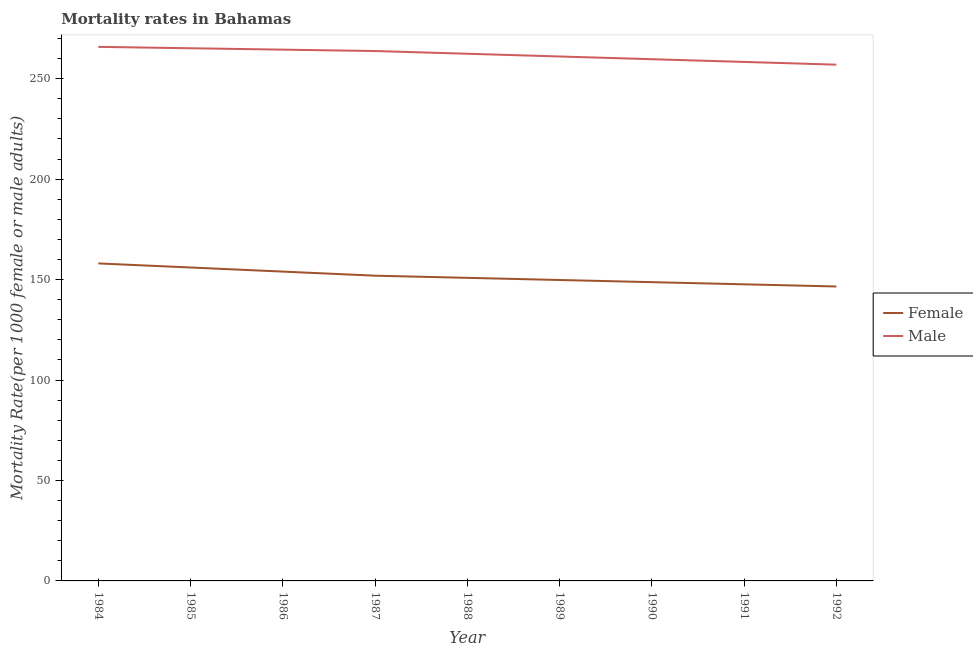How many different coloured lines are there?
Provide a short and direct response. 2. Does the line corresponding to female mortality rate intersect with the line corresponding to male mortality rate?
Give a very brief answer. No. Is the number of lines equal to the number of legend labels?
Make the answer very short. Yes. What is the female mortality rate in 1991?
Your answer should be very brief. 147.63. Across all years, what is the maximum female mortality rate?
Give a very brief answer. 158.03. Across all years, what is the minimum male mortality rate?
Your answer should be compact. 256.96. In which year was the male mortality rate maximum?
Ensure brevity in your answer.  1984. What is the total female mortality rate in the graph?
Your response must be concise. 1363.4. What is the difference between the male mortality rate in 1988 and that in 1990?
Offer a very short reply. 2.71. What is the difference between the female mortality rate in 1986 and the male mortality rate in 1984?
Ensure brevity in your answer.  -111.86. What is the average female mortality rate per year?
Ensure brevity in your answer.  151.49. In the year 1992, what is the difference between the male mortality rate and female mortality rate?
Your response must be concise. 110.41. What is the ratio of the male mortality rate in 1987 to that in 1991?
Your response must be concise. 1.02. Is the male mortality rate in 1985 less than that in 1989?
Your response must be concise. No. Is the difference between the male mortality rate in 1988 and 1991 greater than the difference between the female mortality rate in 1988 and 1991?
Make the answer very short. Yes. What is the difference between the highest and the second highest female mortality rate?
Offer a very short reply. 2.04. What is the difference between the highest and the lowest male mortality rate?
Your answer should be compact. 8.86. Is the sum of the male mortality rate in 1986 and 1992 greater than the maximum female mortality rate across all years?
Your response must be concise. Yes. Does the female mortality rate monotonically increase over the years?
Keep it short and to the point. No. How many lines are there?
Give a very brief answer. 2. What is the difference between two consecutive major ticks on the Y-axis?
Ensure brevity in your answer.  50. How are the legend labels stacked?
Provide a short and direct response. Vertical. What is the title of the graph?
Offer a terse response. Mortality rates in Bahamas. What is the label or title of the X-axis?
Your answer should be compact. Year. What is the label or title of the Y-axis?
Ensure brevity in your answer.  Mortality Rate(per 1000 female or male adults). What is the Mortality Rate(per 1000 female or male adults) in Female in 1984?
Give a very brief answer. 158.03. What is the Mortality Rate(per 1000 female or male adults) in Male in 1984?
Provide a short and direct response. 265.82. What is the Mortality Rate(per 1000 female or male adults) in Female in 1985?
Give a very brief answer. 155.99. What is the Mortality Rate(per 1000 female or male adults) of Male in 1985?
Keep it short and to the point. 265.12. What is the Mortality Rate(per 1000 female or male adults) of Female in 1986?
Provide a short and direct response. 153.96. What is the Mortality Rate(per 1000 female or male adults) of Male in 1986?
Provide a succinct answer. 264.43. What is the Mortality Rate(per 1000 female or male adults) in Female in 1987?
Provide a short and direct response. 151.92. What is the Mortality Rate(per 1000 female or male adults) in Male in 1987?
Ensure brevity in your answer.  263.74. What is the Mortality Rate(per 1000 female or male adults) in Female in 1988?
Offer a very short reply. 150.85. What is the Mortality Rate(per 1000 female or male adults) of Male in 1988?
Keep it short and to the point. 262.38. What is the Mortality Rate(per 1000 female or male adults) of Female in 1989?
Make the answer very short. 149.77. What is the Mortality Rate(per 1000 female or male adults) of Male in 1989?
Provide a succinct answer. 261.03. What is the Mortality Rate(per 1000 female or male adults) in Female in 1990?
Offer a terse response. 148.7. What is the Mortality Rate(per 1000 female or male adults) of Male in 1990?
Give a very brief answer. 259.67. What is the Mortality Rate(per 1000 female or male adults) of Female in 1991?
Your answer should be compact. 147.63. What is the Mortality Rate(per 1000 female or male adults) of Male in 1991?
Offer a very short reply. 258.32. What is the Mortality Rate(per 1000 female or male adults) in Female in 1992?
Offer a very short reply. 146.55. What is the Mortality Rate(per 1000 female or male adults) in Male in 1992?
Keep it short and to the point. 256.96. Across all years, what is the maximum Mortality Rate(per 1000 female or male adults) of Female?
Offer a terse response. 158.03. Across all years, what is the maximum Mortality Rate(per 1000 female or male adults) of Male?
Offer a very short reply. 265.82. Across all years, what is the minimum Mortality Rate(per 1000 female or male adults) in Female?
Provide a short and direct response. 146.55. Across all years, what is the minimum Mortality Rate(per 1000 female or male adults) of Male?
Provide a short and direct response. 256.96. What is the total Mortality Rate(per 1000 female or male adults) in Female in the graph?
Keep it short and to the point. 1363.4. What is the total Mortality Rate(per 1000 female or male adults) in Male in the graph?
Make the answer very short. 2357.48. What is the difference between the Mortality Rate(per 1000 female or male adults) of Female in 1984 and that in 1985?
Offer a terse response. 2.04. What is the difference between the Mortality Rate(per 1000 female or male adults) of Male in 1984 and that in 1985?
Provide a short and direct response. 0.69. What is the difference between the Mortality Rate(per 1000 female or male adults) in Female in 1984 and that in 1986?
Give a very brief answer. 4.07. What is the difference between the Mortality Rate(per 1000 female or male adults) in Male in 1984 and that in 1986?
Provide a short and direct response. 1.38. What is the difference between the Mortality Rate(per 1000 female or male adults) of Female in 1984 and that in 1987?
Give a very brief answer. 6.11. What is the difference between the Mortality Rate(per 1000 female or male adults) of Male in 1984 and that in 1987?
Keep it short and to the point. 2.08. What is the difference between the Mortality Rate(per 1000 female or male adults) in Female in 1984 and that in 1988?
Give a very brief answer. 7.18. What is the difference between the Mortality Rate(per 1000 female or male adults) in Male in 1984 and that in 1988?
Your answer should be very brief. 3.43. What is the difference between the Mortality Rate(per 1000 female or male adults) in Female in 1984 and that in 1989?
Provide a succinct answer. 8.26. What is the difference between the Mortality Rate(per 1000 female or male adults) in Male in 1984 and that in 1989?
Give a very brief answer. 4.79. What is the difference between the Mortality Rate(per 1000 female or male adults) in Female in 1984 and that in 1990?
Keep it short and to the point. 9.33. What is the difference between the Mortality Rate(per 1000 female or male adults) in Male in 1984 and that in 1990?
Provide a succinct answer. 6.14. What is the difference between the Mortality Rate(per 1000 female or male adults) in Female in 1984 and that in 1991?
Your answer should be very brief. 10.4. What is the difference between the Mortality Rate(per 1000 female or male adults) of Male in 1984 and that in 1991?
Offer a terse response. 7.5. What is the difference between the Mortality Rate(per 1000 female or male adults) in Female in 1984 and that in 1992?
Your response must be concise. 11.48. What is the difference between the Mortality Rate(per 1000 female or male adults) in Male in 1984 and that in 1992?
Provide a short and direct response. 8.86. What is the difference between the Mortality Rate(per 1000 female or male adults) in Female in 1985 and that in 1986?
Offer a very short reply. 2.04. What is the difference between the Mortality Rate(per 1000 female or male adults) of Male in 1985 and that in 1986?
Give a very brief answer. 0.69. What is the difference between the Mortality Rate(per 1000 female or male adults) of Female in 1985 and that in 1987?
Ensure brevity in your answer.  4.07. What is the difference between the Mortality Rate(per 1000 female or male adults) in Male in 1985 and that in 1987?
Your response must be concise. 1.38. What is the difference between the Mortality Rate(per 1000 female or male adults) in Female in 1985 and that in 1988?
Offer a terse response. 5.15. What is the difference between the Mortality Rate(per 1000 female or male adults) of Male in 1985 and that in 1988?
Provide a short and direct response. 2.74. What is the difference between the Mortality Rate(per 1000 female or male adults) in Female in 1985 and that in 1989?
Make the answer very short. 6.22. What is the difference between the Mortality Rate(per 1000 female or male adults) of Male in 1985 and that in 1989?
Your response must be concise. 4.1. What is the difference between the Mortality Rate(per 1000 female or male adults) of Female in 1985 and that in 1990?
Offer a very short reply. 7.29. What is the difference between the Mortality Rate(per 1000 female or male adults) of Male in 1985 and that in 1990?
Give a very brief answer. 5.45. What is the difference between the Mortality Rate(per 1000 female or male adults) of Female in 1985 and that in 1991?
Your answer should be very brief. 8.37. What is the difference between the Mortality Rate(per 1000 female or male adults) in Male in 1985 and that in 1991?
Provide a short and direct response. 6.81. What is the difference between the Mortality Rate(per 1000 female or male adults) in Female in 1985 and that in 1992?
Make the answer very short. 9.44. What is the difference between the Mortality Rate(per 1000 female or male adults) of Male in 1985 and that in 1992?
Offer a terse response. 8.16. What is the difference between the Mortality Rate(per 1000 female or male adults) of Female in 1986 and that in 1987?
Make the answer very short. 2.04. What is the difference between the Mortality Rate(per 1000 female or male adults) of Male in 1986 and that in 1987?
Ensure brevity in your answer.  0.69. What is the difference between the Mortality Rate(per 1000 female or male adults) in Female in 1986 and that in 1988?
Offer a very short reply. 3.11. What is the difference between the Mortality Rate(per 1000 female or male adults) in Male in 1986 and that in 1988?
Give a very brief answer. 2.05. What is the difference between the Mortality Rate(per 1000 female or male adults) of Female in 1986 and that in 1989?
Make the answer very short. 4.18. What is the difference between the Mortality Rate(per 1000 female or male adults) of Male in 1986 and that in 1989?
Keep it short and to the point. 3.4. What is the difference between the Mortality Rate(per 1000 female or male adults) of Female in 1986 and that in 1990?
Your answer should be very brief. 5.26. What is the difference between the Mortality Rate(per 1000 female or male adults) in Male in 1986 and that in 1990?
Your answer should be compact. 4.76. What is the difference between the Mortality Rate(per 1000 female or male adults) in Female in 1986 and that in 1991?
Your answer should be compact. 6.33. What is the difference between the Mortality Rate(per 1000 female or male adults) of Male in 1986 and that in 1991?
Make the answer very short. 6.12. What is the difference between the Mortality Rate(per 1000 female or male adults) in Female in 1986 and that in 1992?
Provide a succinct answer. 7.41. What is the difference between the Mortality Rate(per 1000 female or male adults) of Male in 1986 and that in 1992?
Your response must be concise. 7.47. What is the difference between the Mortality Rate(per 1000 female or male adults) of Female in 1987 and that in 1988?
Make the answer very short. 1.07. What is the difference between the Mortality Rate(per 1000 female or male adults) in Male in 1987 and that in 1988?
Offer a very short reply. 1.36. What is the difference between the Mortality Rate(per 1000 female or male adults) in Female in 1987 and that in 1989?
Your response must be concise. 2.15. What is the difference between the Mortality Rate(per 1000 female or male adults) of Male in 1987 and that in 1989?
Your answer should be very brief. 2.71. What is the difference between the Mortality Rate(per 1000 female or male adults) in Female in 1987 and that in 1990?
Offer a very short reply. 3.22. What is the difference between the Mortality Rate(per 1000 female or male adults) of Male in 1987 and that in 1990?
Ensure brevity in your answer.  4.07. What is the difference between the Mortality Rate(per 1000 female or male adults) of Female in 1987 and that in 1991?
Keep it short and to the point. 4.3. What is the difference between the Mortality Rate(per 1000 female or male adults) in Male in 1987 and that in 1991?
Your answer should be very brief. 5.42. What is the difference between the Mortality Rate(per 1000 female or male adults) of Female in 1987 and that in 1992?
Provide a short and direct response. 5.37. What is the difference between the Mortality Rate(per 1000 female or male adults) of Male in 1987 and that in 1992?
Keep it short and to the point. 6.78. What is the difference between the Mortality Rate(per 1000 female or male adults) in Female in 1988 and that in 1989?
Your answer should be very brief. 1.07. What is the difference between the Mortality Rate(per 1000 female or male adults) in Male in 1988 and that in 1989?
Offer a very short reply. 1.36. What is the difference between the Mortality Rate(per 1000 female or male adults) of Female in 1988 and that in 1990?
Your response must be concise. 2.15. What is the difference between the Mortality Rate(per 1000 female or male adults) of Male in 1988 and that in 1990?
Your response must be concise. 2.71. What is the difference between the Mortality Rate(per 1000 female or male adults) of Female in 1988 and that in 1991?
Offer a very short reply. 3.22. What is the difference between the Mortality Rate(per 1000 female or male adults) in Male in 1988 and that in 1991?
Keep it short and to the point. 4.07. What is the difference between the Mortality Rate(per 1000 female or male adults) of Female in 1988 and that in 1992?
Provide a succinct answer. 4.3. What is the difference between the Mortality Rate(per 1000 female or male adults) of Male in 1988 and that in 1992?
Offer a terse response. 5.42. What is the difference between the Mortality Rate(per 1000 female or male adults) in Female in 1989 and that in 1990?
Ensure brevity in your answer.  1.07. What is the difference between the Mortality Rate(per 1000 female or male adults) of Male in 1989 and that in 1990?
Offer a very short reply. 1.36. What is the difference between the Mortality Rate(per 1000 female or male adults) of Female in 1989 and that in 1991?
Offer a very short reply. 2.15. What is the difference between the Mortality Rate(per 1000 female or male adults) in Male in 1989 and that in 1991?
Your response must be concise. 2.71. What is the difference between the Mortality Rate(per 1000 female or male adults) of Female in 1989 and that in 1992?
Give a very brief answer. 3.22. What is the difference between the Mortality Rate(per 1000 female or male adults) in Male in 1989 and that in 1992?
Give a very brief answer. 4.07. What is the difference between the Mortality Rate(per 1000 female or male adults) of Female in 1990 and that in 1991?
Your response must be concise. 1.07. What is the difference between the Mortality Rate(per 1000 female or male adults) of Male in 1990 and that in 1991?
Your answer should be compact. 1.36. What is the difference between the Mortality Rate(per 1000 female or male adults) of Female in 1990 and that in 1992?
Provide a short and direct response. 2.15. What is the difference between the Mortality Rate(per 1000 female or male adults) in Male in 1990 and that in 1992?
Provide a succinct answer. 2.71. What is the difference between the Mortality Rate(per 1000 female or male adults) of Female in 1991 and that in 1992?
Your answer should be very brief. 1.07. What is the difference between the Mortality Rate(per 1000 female or male adults) of Male in 1991 and that in 1992?
Give a very brief answer. 1.36. What is the difference between the Mortality Rate(per 1000 female or male adults) in Female in 1984 and the Mortality Rate(per 1000 female or male adults) in Male in 1985?
Provide a short and direct response. -107.09. What is the difference between the Mortality Rate(per 1000 female or male adults) of Female in 1984 and the Mortality Rate(per 1000 female or male adults) of Male in 1986?
Your answer should be very brief. -106.4. What is the difference between the Mortality Rate(per 1000 female or male adults) of Female in 1984 and the Mortality Rate(per 1000 female or male adults) of Male in 1987?
Your answer should be compact. -105.71. What is the difference between the Mortality Rate(per 1000 female or male adults) in Female in 1984 and the Mortality Rate(per 1000 female or male adults) in Male in 1988?
Provide a short and direct response. -104.36. What is the difference between the Mortality Rate(per 1000 female or male adults) of Female in 1984 and the Mortality Rate(per 1000 female or male adults) of Male in 1989?
Provide a short and direct response. -103. What is the difference between the Mortality Rate(per 1000 female or male adults) in Female in 1984 and the Mortality Rate(per 1000 female or male adults) in Male in 1990?
Your response must be concise. -101.64. What is the difference between the Mortality Rate(per 1000 female or male adults) of Female in 1984 and the Mortality Rate(per 1000 female or male adults) of Male in 1991?
Make the answer very short. -100.29. What is the difference between the Mortality Rate(per 1000 female or male adults) of Female in 1984 and the Mortality Rate(per 1000 female or male adults) of Male in 1992?
Offer a very short reply. -98.93. What is the difference between the Mortality Rate(per 1000 female or male adults) in Female in 1985 and the Mortality Rate(per 1000 female or male adults) in Male in 1986?
Your answer should be compact. -108.44. What is the difference between the Mortality Rate(per 1000 female or male adults) of Female in 1985 and the Mortality Rate(per 1000 female or male adults) of Male in 1987?
Your answer should be compact. -107.75. What is the difference between the Mortality Rate(per 1000 female or male adults) of Female in 1985 and the Mortality Rate(per 1000 female or male adults) of Male in 1988?
Ensure brevity in your answer.  -106.39. What is the difference between the Mortality Rate(per 1000 female or male adults) of Female in 1985 and the Mortality Rate(per 1000 female or male adults) of Male in 1989?
Provide a succinct answer. -105.03. What is the difference between the Mortality Rate(per 1000 female or male adults) of Female in 1985 and the Mortality Rate(per 1000 female or male adults) of Male in 1990?
Make the answer very short. -103.68. What is the difference between the Mortality Rate(per 1000 female or male adults) in Female in 1985 and the Mortality Rate(per 1000 female or male adults) in Male in 1991?
Make the answer very short. -102.32. What is the difference between the Mortality Rate(per 1000 female or male adults) in Female in 1985 and the Mortality Rate(per 1000 female or male adults) in Male in 1992?
Keep it short and to the point. -100.97. What is the difference between the Mortality Rate(per 1000 female or male adults) of Female in 1986 and the Mortality Rate(per 1000 female or male adults) of Male in 1987?
Your answer should be very brief. -109.78. What is the difference between the Mortality Rate(per 1000 female or male adults) in Female in 1986 and the Mortality Rate(per 1000 female or male adults) in Male in 1988?
Offer a terse response. -108.43. What is the difference between the Mortality Rate(per 1000 female or male adults) in Female in 1986 and the Mortality Rate(per 1000 female or male adults) in Male in 1989?
Offer a terse response. -107.07. What is the difference between the Mortality Rate(per 1000 female or male adults) of Female in 1986 and the Mortality Rate(per 1000 female or male adults) of Male in 1990?
Provide a short and direct response. -105.71. What is the difference between the Mortality Rate(per 1000 female or male adults) of Female in 1986 and the Mortality Rate(per 1000 female or male adults) of Male in 1991?
Offer a terse response. -104.36. What is the difference between the Mortality Rate(per 1000 female or male adults) of Female in 1986 and the Mortality Rate(per 1000 female or male adults) of Male in 1992?
Offer a terse response. -103. What is the difference between the Mortality Rate(per 1000 female or male adults) in Female in 1987 and the Mortality Rate(per 1000 female or male adults) in Male in 1988?
Provide a succinct answer. -110.46. What is the difference between the Mortality Rate(per 1000 female or male adults) of Female in 1987 and the Mortality Rate(per 1000 female or male adults) of Male in 1989?
Offer a terse response. -109.11. What is the difference between the Mortality Rate(per 1000 female or male adults) of Female in 1987 and the Mortality Rate(per 1000 female or male adults) of Male in 1990?
Offer a terse response. -107.75. What is the difference between the Mortality Rate(per 1000 female or male adults) in Female in 1987 and the Mortality Rate(per 1000 female or male adults) in Male in 1991?
Provide a short and direct response. -106.39. What is the difference between the Mortality Rate(per 1000 female or male adults) in Female in 1987 and the Mortality Rate(per 1000 female or male adults) in Male in 1992?
Offer a very short reply. -105.04. What is the difference between the Mortality Rate(per 1000 female or male adults) of Female in 1988 and the Mortality Rate(per 1000 female or male adults) of Male in 1989?
Provide a short and direct response. -110.18. What is the difference between the Mortality Rate(per 1000 female or male adults) of Female in 1988 and the Mortality Rate(per 1000 female or male adults) of Male in 1990?
Your response must be concise. -108.82. What is the difference between the Mortality Rate(per 1000 female or male adults) in Female in 1988 and the Mortality Rate(per 1000 female or male adults) in Male in 1991?
Offer a terse response. -107.47. What is the difference between the Mortality Rate(per 1000 female or male adults) in Female in 1988 and the Mortality Rate(per 1000 female or male adults) in Male in 1992?
Your answer should be compact. -106.11. What is the difference between the Mortality Rate(per 1000 female or male adults) of Female in 1989 and the Mortality Rate(per 1000 female or male adults) of Male in 1990?
Provide a short and direct response. -109.9. What is the difference between the Mortality Rate(per 1000 female or male adults) in Female in 1989 and the Mortality Rate(per 1000 female or male adults) in Male in 1991?
Your response must be concise. -108.54. What is the difference between the Mortality Rate(per 1000 female or male adults) in Female in 1989 and the Mortality Rate(per 1000 female or male adults) in Male in 1992?
Offer a terse response. -107.19. What is the difference between the Mortality Rate(per 1000 female or male adults) of Female in 1990 and the Mortality Rate(per 1000 female or male adults) of Male in 1991?
Your response must be concise. -109.62. What is the difference between the Mortality Rate(per 1000 female or male adults) in Female in 1990 and the Mortality Rate(per 1000 female or male adults) in Male in 1992?
Keep it short and to the point. -108.26. What is the difference between the Mortality Rate(per 1000 female or male adults) in Female in 1991 and the Mortality Rate(per 1000 female or male adults) in Male in 1992?
Ensure brevity in your answer.  -109.33. What is the average Mortality Rate(per 1000 female or male adults) in Female per year?
Offer a terse response. 151.49. What is the average Mortality Rate(per 1000 female or male adults) in Male per year?
Offer a terse response. 261.94. In the year 1984, what is the difference between the Mortality Rate(per 1000 female or male adults) in Female and Mortality Rate(per 1000 female or male adults) in Male?
Your answer should be compact. -107.79. In the year 1985, what is the difference between the Mortality Rate(per 1000 female or male adults) in Female and Mortality Rate(per 1000 female or male adults) in Male?
Provide a short and direct response. -109.13. In the year 1986, what is the difference between the Mortality Rate(per 1000 female or male adults) of Female and Mortality Rate(per 1000 female or male adults) of Male?
Make the answer very short. -110.47. In the year 1987, what is the difference between the Mortality Rate(per 1000 female or male adults) in Female and Mortality Rate(per 1000 female or male adults) in Male?
Your answer should be compact. -111.82. In the year 1988, what is the difference between the Mortality Rate(per 1000 female or male adults) in Female and Mortality Rate(per 1000 female or male adults) in Male?
Keep it short and to the point. -111.54. In the year 1989, what is the difference between the Mortality Rate(per 1000 female or male adults) in Female and Mortality Rate(per 1000 female or male adults) in Male?
Ensure brevity in your answer.  -111.25. In the year 1990, what is the difference between the Mortality Rate(per 1000 female or male adults) of Female and Mortality Rate(per 1000 female or male adults) of Male?
Provide a succinct answer. -110.97. In the year 1991, what is the difference between the Mortality Rate(per 1000 female or male adults) of Female and Mortality Rate(per 1000 female or male adults) of Male?
Ensure brevity in your answer.  -110.69. In the year 1992, what is the difference between the Mortality Rate(per 1000 female or male adults) in Female and Mortality Rate(per 1000 female or male adults) in Male?
Provide a short and direct response. -110.41. What is the ratio of the Mortality Rate(per 1000 female or male adults) in Female in 1984 to that in 1985?
Your response must be concise. 1.01. What is the ratio of the Mortality Rate(per 1000 female or male adults) in Male in 1984 to that in 1985?
Provide a short and direct response. 1. What is the ratio of the Mortality Rate(per 1000 female or male adults) in Female in 1984 to that in 1986?
Provide a succinct answer. 1.03. What is the ratio of the Mortality Rate(per 1000 female or male adults) of Male in 1984 to that in 1986?
Provide a short and direct response. 1.01. What is the ratio of the Mortality Rate(per 1000 female or male adults) in Female in 1984 to that in 1987?
Give a very brief answer. 1.04. What is the ratio of the Mortality Rate(per 1000 female or male adults) of Male in 1984 to that in 1987?
Keep it short and to the point. 1.01. What is the ratio of the Mortality Rate(per 1000 female or male adults) in Female in 1984 to that in 1988?
Your response must be concise. 1.05. What is the ratio of the Mortality Rate(per 1000 female or male adults) in Male in 1984 to that in 1988?
Provide a succinct answer. 1.01. What is the ratio of the Mortality Rate(per 1000 female or male adults) in Female in 1984 to that in 1989?
Your answer should be compact. 1.06. What is the ratio of the Mortality Rate(per 1000 female or male adults) of Male in 1984 to that in 1989?
Your answer should be compact. 1.02. What is the ratio of the Mortality Rate(per 1000 female or male adults) in Female in 1984 to that in 1990?
Provide a succinct answer. 1.06. What is the ratio of the Mortality Rate(per 1000 female or male adults) of Male in 1984 to that in 1990?
Your response must be concise. 1.02. What is the ratio of the Mortality Rate(per 1000 female or male adults) of Female in 1984 to that in 1991?
Offer a very short reply. 1.07. What is the ratio of the Mortality Rate(per 1000 female or male adults) of Male in 1984 to that in 1991?
Offer a terse response. 1.03. What is the ratio of the Mortality Rate(per 1000 female or male adults) in Female in 1984 to that in 1992?
Your answer should be very brief. 1.08. What is the ratio of the Mortality Rate(per 1000 female or male adults) of Male in 1984 to that in 1992?
Offer a terse response. 1.03. What is the ratio of the Mortality Rate(per 1000 female or male adults) in Female in 1985 to that in 1986?
Your response must be concise. 1.01. What is the ratio of the Mortality Rate(per 1000 female or male adults) in Female in 1985 to that in 1987?
Your response must be concise. 1.03. What is the ratio of the Mortality Rate(per 1000 female or male adults) of Female in 1985 to that in 1988?
Provide a succinct answer. 1.03. What is the ratio of the Mortality Rate(per 1000 female or male adults) in Male in 1985 to that in 1988?
Ensure brevity in your answer.  1.01. What is the ratio of the Mortality Rate(per 1000 female or male adults) in Female in 1985 to that in 1989?
Offer a terse response. 1.04. What is the ratio of the Mortality Rate(per 1000 female or male adults) of Male in 1985 to that in 1989?
Your response must be concise. 1.02. What is the ratio of the Mortality Rate(per 1000 female or male adults) of Female in 1985 to that in 1990?
Give a very brief answer. 1.05. What is the ratio of the Mortality Rate(per 1000 female or male adults) of Female in 1985 to that in 1991?
Offer a very short reply. 1.06. What is the ratio of the Mortality Rate(per 1000 female or male adults) of Male in 1985 to that in 1991?
Your response must be concise. 1.03. What is the ratio of the Mortality Rate(per 1000 female or male adults) of Female in 1985 to that in 1992?
Your response must be concise. 1.06. What is the ratio of the Mortality Rate(per 1000 female or male adults) of Male in 1985 to that in 1992?
Give a very brief answer. 1.03. What is the ratio of the Mortality Rate(per 1000 female or male adults) of Female in 1986 to that in 1987?
Ensure brevity in your answer.  1.01. What is the ratio of the Mortality Rate(per 1000 female or male adults) in Female in 1986 to that in 1988?
Give a very brief answer. 1.02. What is the ratio of the Mortality Rate(per 1000 female or male adults) of Male in 1986 to that in 1988?
Offer a very short reply. 1.01. What is the ratio of the Mortality Rate(per 1000 female or male adults) of Female in 1986 to that in 1989?
Provide a succinct answer. 1.03. What is the ratio of the Mortality Rate(per 1000 female or male adults) in Female in 1986 to that in 1990?
Your response must be concise. 1.04. What is the ratio of the Mortality Rate(per 1000 female or male adults) of Male in 1986 to that in 1990?
Ensure brevity in your answer.  1.02. What is the ratio of the Mortality Rate(per 1000 female or male adults) of Female in 1986 to that in 1991?
Offer a terse response. 1.04. What is the ratio of the Mortality Rate(per 1000 female or male adults) in Male in 1986 to that in 1991?
Your answer should be compact. 1.02. What is the ratio of the Mortality Rate(per 1000 female or male adults) in Female in 1986 to that in 1992?
Your response must be concise. 1.05. What is the ratio of the Mortality Rate(per 1000 female or male adults) in Male in 1986 to that in 1992?
Your answer should be compact. 1.03. What is the ratio of the Mortality Rate(per 1000 female or male adults) of Female in 1987 to that in 1988?
Your answer should be very brief. 1.01. What is the ratio of the Mortality Rate(per 1000 female or male adults) in Male in 1987 to that in 1988?
Offer a terse response. 1.01. What is the ratio of the Mortality Rate(per 1000 female or male adults) in Female in 1987 to that in 1989?
Your answer should be compact. 1.01. What is the ratio of the Mortality Rate(per 1000 female or male adults) in Male in 1987 to that in 1989?
Offer a terse response. 1.01. What is the ratio of the Mortality Rate(per 1000 female or male adults) in Female in 1987 to that in 1990?
Ensure brevity in your answer.  1.02. What is the ratio of the Mortality Rate(per 1000 female or male adults) in Male in 1987 to that in 1990?
Offer a very short reply. 1.02. What is the ratio of the Mortality Rate(per 1000 female or male adults) of Female in 1987 to that in 1991?
Provide a short and direct response. 1.03. What is the ratio of the Mortality Rate(per 1000 female or male adults) in Female in 1987 to that in 1992?
Give a very brief answer. 1.04. What is the ratio of the Mortality Rate(per 1000 female or male adults) in Male in 1987 to that in 1992?
Ensure brevity in your answer.  1.03. What is the ratio of the Mortality Rate(per 1000 female or male adults) in Female in 1988 to that in 1989?
Offer a terse response. 1.01. What is the ratio of the Mortality Rate(per 1000 female or male adults) in Male in 1988 to that in 1989?
Provide a succinct answer. 1.01. What is the ratio of the Mortality Rate(per 1000 female or male adults) in Female in 1988 to that in 1990?
Make the answer very short. 1.01. What is the ratio of the Mortality Rate(per 1000 female or male adults) in Male in 1988 to that in 1990?
Provide a succinct answer. 1.01. What is the ratio of the Mortality Rate(per 1000 female or male adults) of Female in 1988 to that in 1991?
Offer a very short reply. 1.02. What is the ratio of the Mortality Rate(per 1000 female or male adults) of Male in 1988 to that in 1991?
Provide a short and direct response. 1.02. What is the ratio of the Mortality Rate(per 1000 female or male adults) of Female in 1988 to that in 1992?
Make the answer very short. 1.03. What is the ratio of the Mortality Rate(per 1000 female or male adults) in Male in 1988 to that in 1992?
Your answer should be very brief. 1.02. What is the ratio of the Mortality Rate(per 1000 female or male adults) of Female in 1989 to that in 1990?
Your answer should be very brief. 1.01. What is the ratio of the Mortality Rate(per 1000 female or male adults) of Male in 1989 to that in 1990?
Ensure brevity in your answer.  1.01. What is the ratio of the Mortality Rate(per 1000 female or male adults) of Female in 1989 to that in 1991?
Give a very brief answer. 1.01. What is the ratio of the Mortality Rate(per 1000 female or male adults) of Male in 1989 to that in 1991?
Ensure brevity in your answer.  1.01. What is the ratio of the Mortality Rate(per 1000 female or male adults) in Female in 1989 to that in 1992?
Provide a succinct answer. 1.02. What is the ratio of the Mortality Rate(per 1000 female or male adults) of Male in 1989 to that in 1992?
Provide a succinct answer. 1.02. What is the ratio of the Mortality Rate(per 1000 female or male adults) in Female in 1990 to that in 1991?
Give a very brief answer. 1.01. What is the ratio of the Mortality Rate(per 1000 female or male adults) of Male in 1990 to that in 1991?
Offer a terse response. 1.01. What is the ratio of the Mortality Rate(per 1000 female or male adults) of Female in 1990 to that in 1992?
Provide a succinct answer. 1.01. What is the ratio of the Mortality Rate(per 1000 female or male adults) in Male in 1990 to that in 1992?
Provide a succinct answer. 1.01. What is the ratio of the Mortality Rate(per 1000 female or male adults) of Female in 1991 to that in 1992?
Offer a terse response. 1.01. What is the difference between the highest and the second highest Mortality Rate(per 1000 female or male adults) of Female?
Provide a short and direct response. 2.04. What is the difference between the highest and the second highest Mortality Rate(per 1000 female or male adults) of Male?
Your answer should be compact. 0.69. What is the difference between the highest and the lowest Mortality Rate(per 1000 female or male adults) in Female?
Offer a very short reply. 11.48. What is the difference between the highest and the lowest Mortality Rate(per 1000 female or male adults) of Male?
Offer a very short reply. 8.86. 